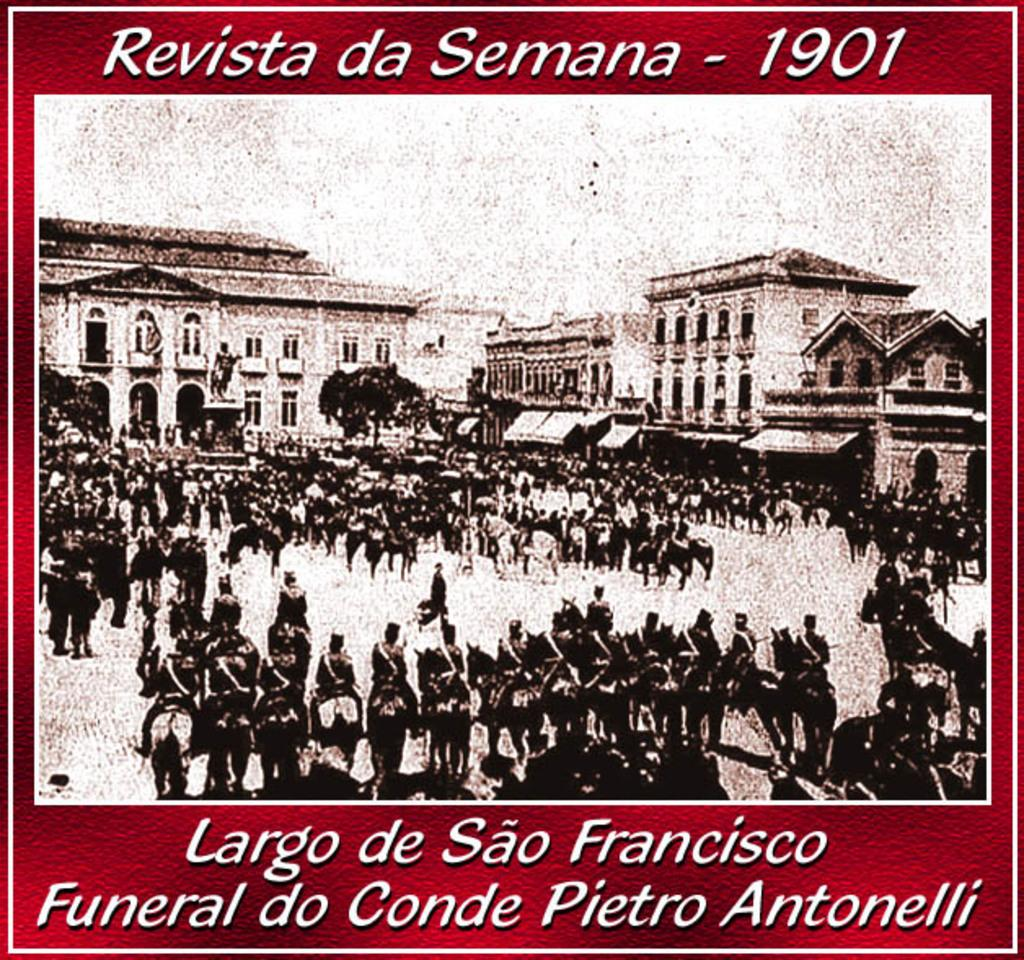<image>
Write a terse but informative summary of the picture. an old poster of a downtown city Revista da samana - 1901 